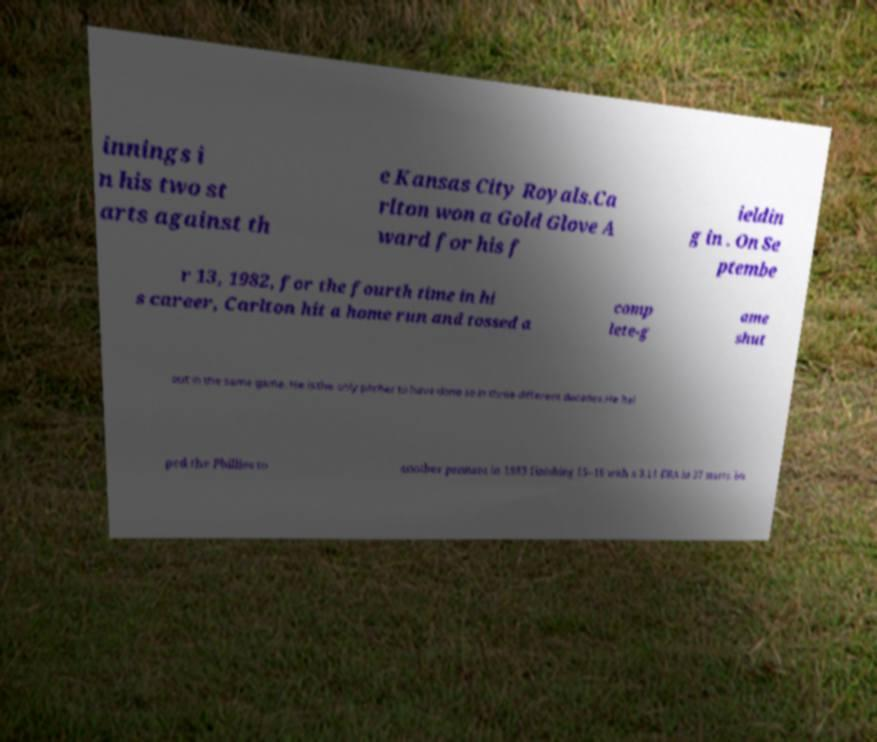Can you read and provide the text displayed in the image?This photo seems to have some interesting text. Can you extract and type it out for me? innings i n his two st arts against th e Kansas City Royals.Ca rlton won a Gold Glove A ward for his f ieldin g in . On Se ptembe r 13, 1982, for the fourth time in hi s career, Carlton hit a home run and tossed a comp lete-g ame shut out in the same game. He is the only pitcher to have done so in three different decades.He hel ped the Phillies to another pennant in 1983 finishing 15–16 with a 3.11 ERA in 37 starts. bu 